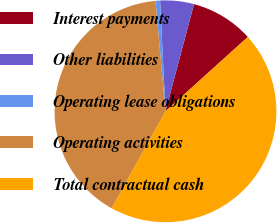<chart> <loc_0><loc_0><loc_500><loc_500><pie_chart><fcel>Interest payments<fcel>Other liabilities<fcel>Operating lease obligations<fcel>Operating activities<fcel>Total contractual cash<nl><fcel>9.17%<fcel>4.92%<fcel>0.66%<fcel>40.49%<fcel>44.75%<nl></chart> 